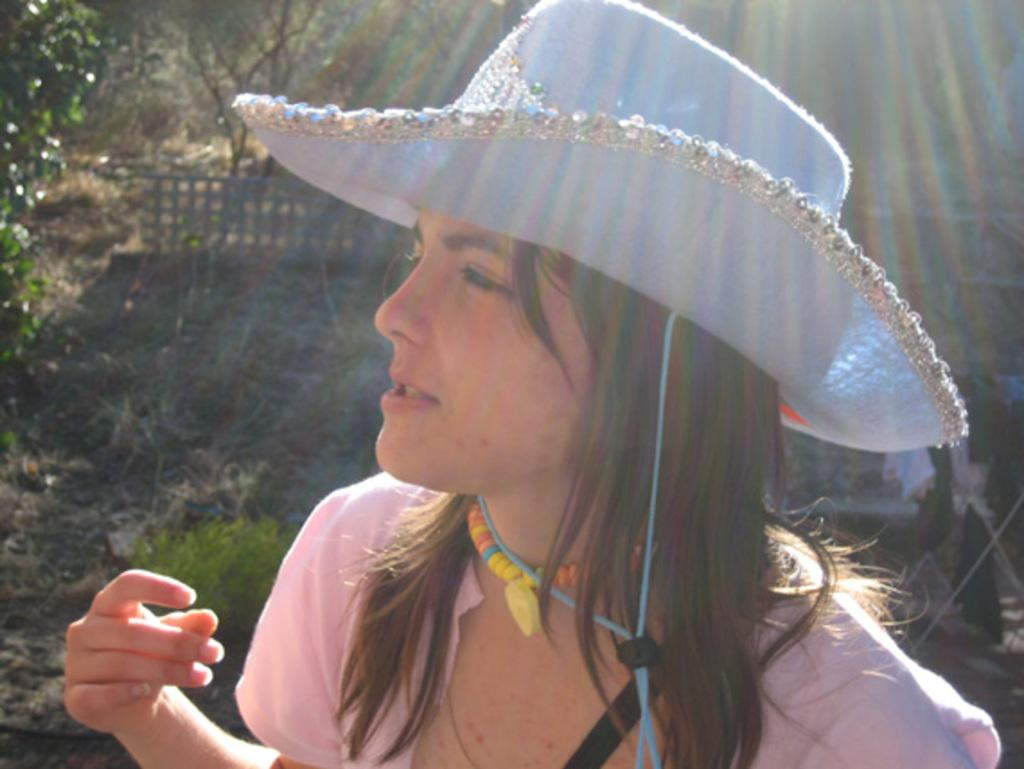What is the person in the image wearing on their head? The person in the image is wearing a hat. What can be seen in the background of the image? There is a metal fence and trees in the background of the image. What page of the book is the person reading in the image? There is no book present in the image, so it is not possible to determine which page the person might be reading. 